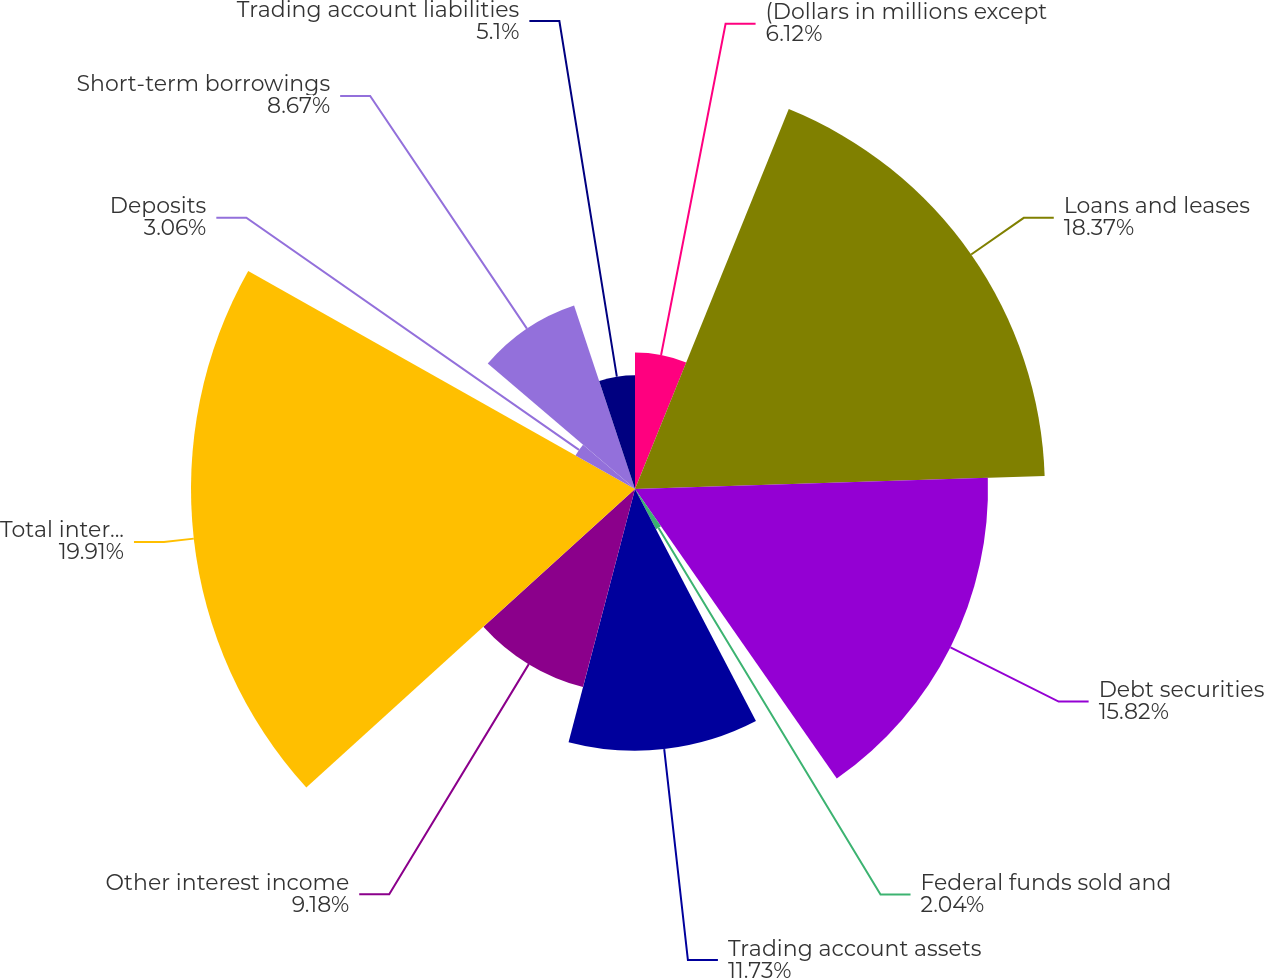Convert chart to OTSL. <chart><loc_0><loc_0><loc_500><loc_500><pie_chart><fcel>(Dollars in millions except<fcel>Loans and leases<fcel>Debt securities<fcel>Federal funds sold and<fcel>Trading account assets<fcel>Other interest income<fcel>Total interest income<fcel>Deposits<fcel>Short-term borrowings<fcel>Trading account liabilities<nl><fcel>6.12%<fcel>18.37%<fcel>15.82%<fcel>2.04%<fcel>11.73%<fcel>9.18%<fcel>19.9%<fcel>3.06%<fcel>8.67%<fcel>5.1%<nl></chart> 